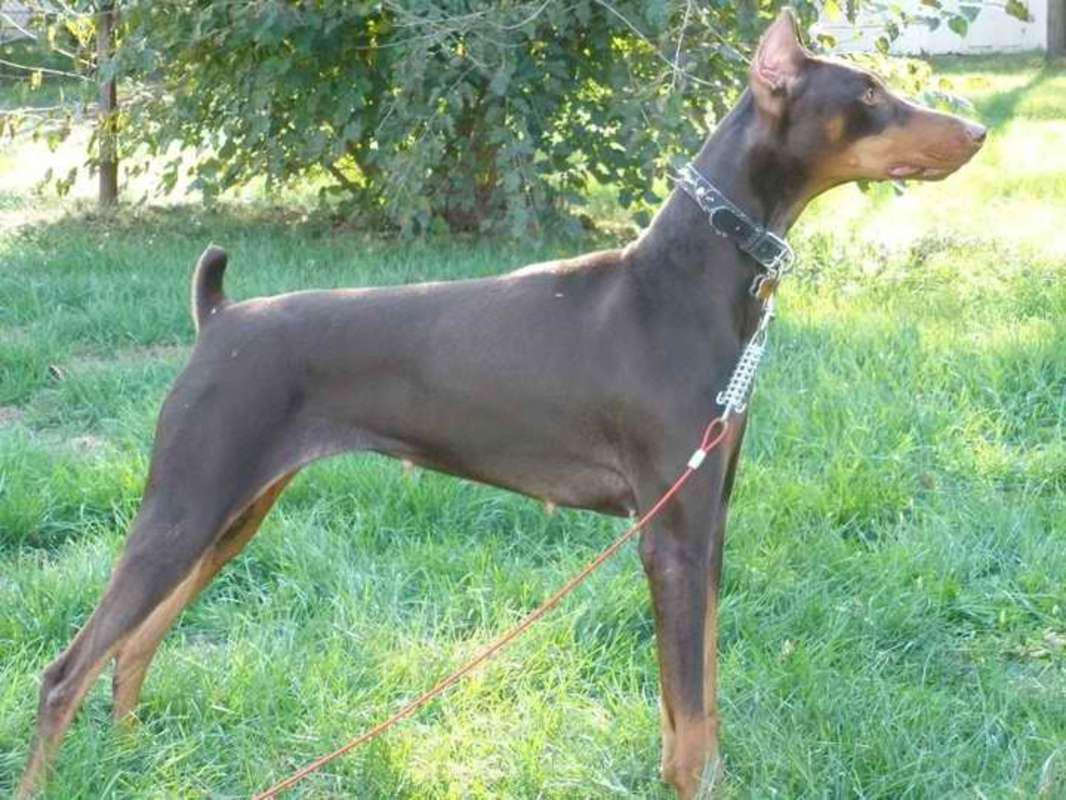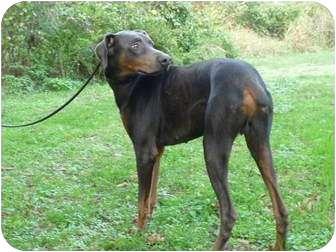The first image is the image on the left, the second image is the image on the right. For the images shown, is this caption "One of the dogs is standing with its head facing left." true? Answer yes or no. No. The first image is the image on the left, the second image is the image on the right. For the images shown, is this caption "One image shows a doberman with erect ears and docked tail standing in profile facing left, and the other image shows a non-standing doberman wearing a collar." true? Answer yes or no. No. 